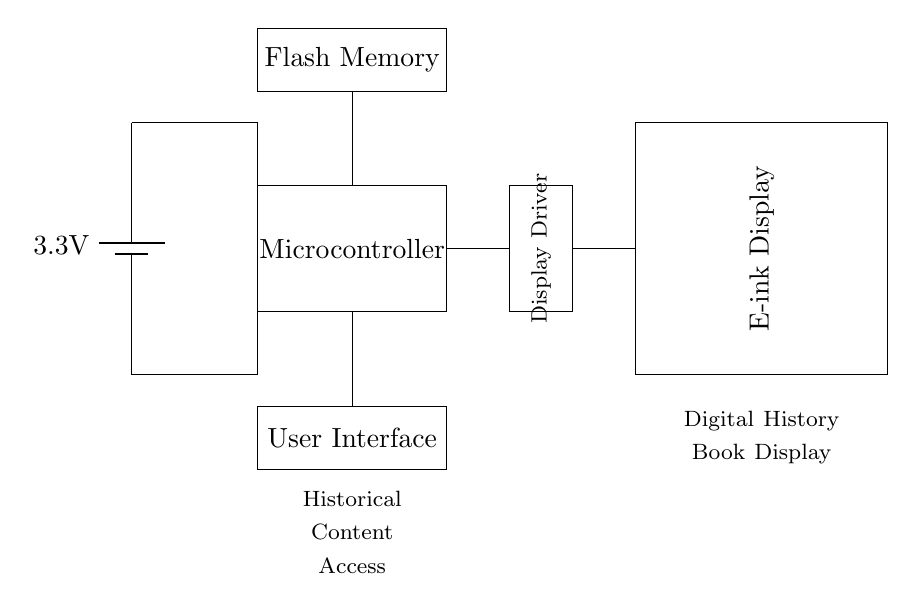What is the voltage of the power supply? The voltage of the power supply is indicated directly in the circuit diagram next to the battery symbol. It shows a value of 3.3 volts.
Answer: 3.3 volts What component connects to the display driver? The component that connects to the display driver is the microcontroller, as indicated by the direct connection line from the microcontroller to the display driver.
Answer: Microcontroller What is the purpose of the flash memory in the circuit? The flash memory stores historical content that can be accessed and displayed by the microcontroller. This is inferred from the label on the flash memory in the diagram which mentions it is for historical content access.
Answer: Store historical content How many main components are shown in the circuit? The circuit diagram features four main components: the power supply, microcontroller, display driver, and E-ink display. This can be counted by visual inspection of the diagram.
Answer: Four What is the label on the user interface? The label on the user interface specifically mentions "User Interface," which is shown directly in the diagram structure where the user interface component is illustrated.
Answer: User Interface Which way does the information flow from the microcontroller? The connection lines indicate that information flows from the microcontroller to the display driver and then to the E-ink display. This is deduced through observing the connection directions in the circuit.
Answer: To the display driver What type of display is used in the circuit? The circuit diagram indicates that the display type utilized is an E-ink display, as labeled in the rectangle representing the display component.
Answer: E-ink display 